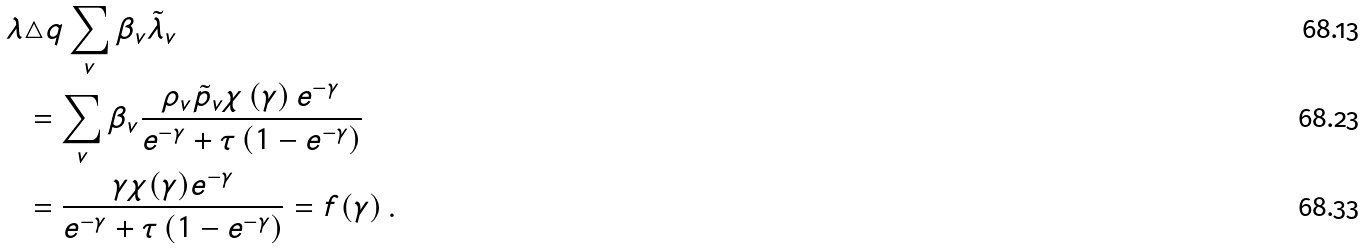<formula> <loc_0><loc_0><loc_500><loc_500>\lambda & \triangle q \sum _ { v } \beta _ { v } \tilde { \lambda } _ { v } \\ & = \sum _ { v } \beta _ { v } \frac { \rho _ { v } \tilde { p } _ { v } \chi \left ( \gamma \right ) e ^ { - \gamma } } { e ^ { - \gamma } + \tau \left ( 1 - e ^ { - \gamma } \right ) } \\ & = \frac { \gamma \chi ( \gamma ) e ^ { - \gamma } } { e ^ { - \gamma } + \tau \left ( 1 - e ^ { - \gamma } \right ) } = f ( \gamma ) \, .</formula> 